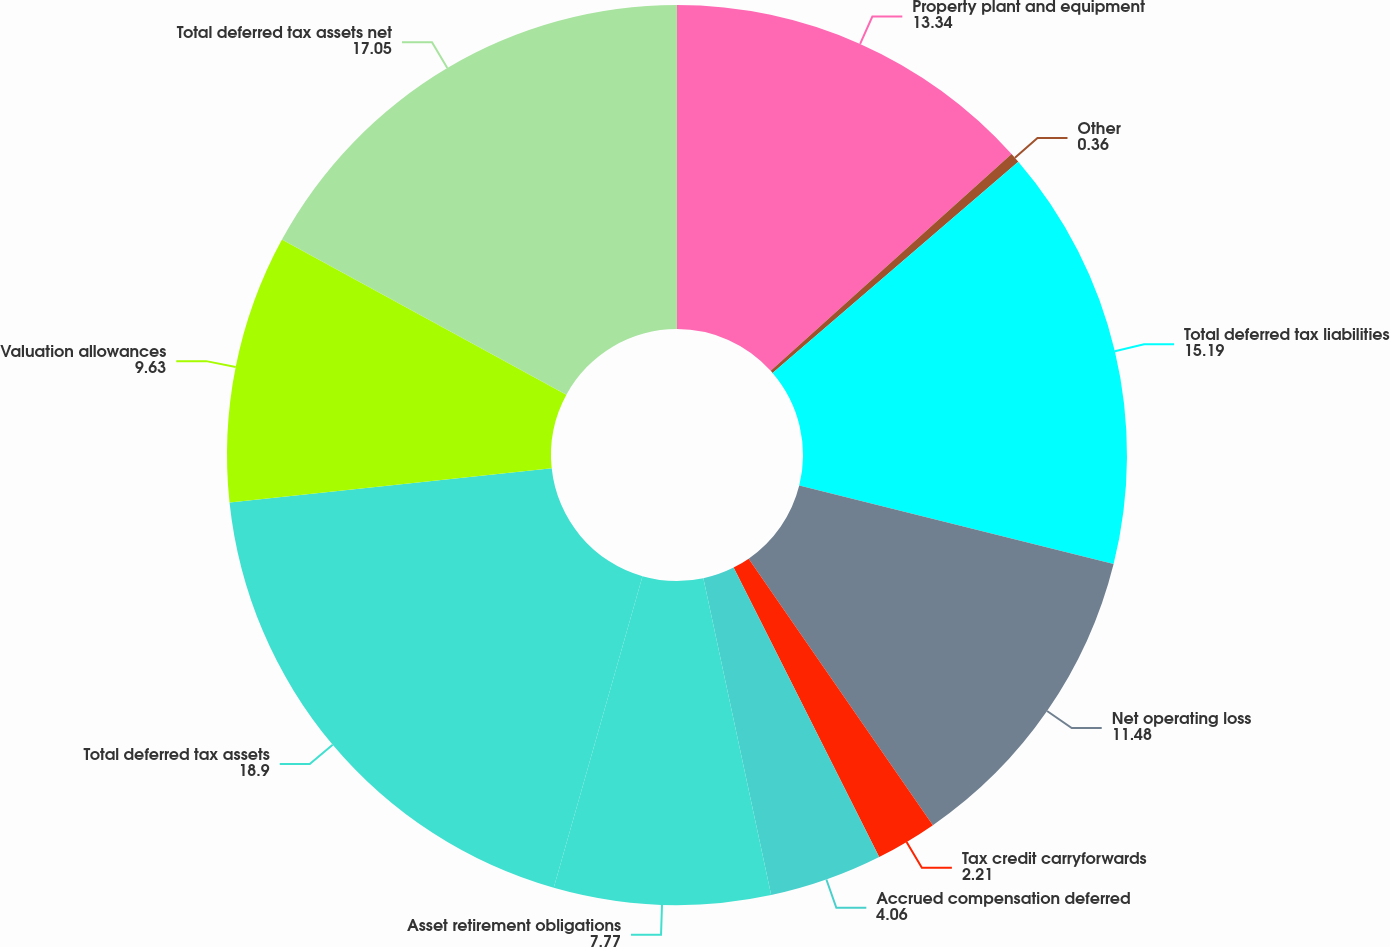Convert chart. <chart><loc_0><loc_0><loc_500><loc_500><pie_chart><fcel>Property plant and equipment<fcel>Other<fcel>Total deferred tax liabilities<fcel>Net operating loss<fcel>Tax credit carryforwards<fcel>Accrued compensation deferred<fcel>Asset retirement obligations<fcel>Total deferred tax assets<fcel>Valuation allowances<fcel>Total deferred tax assets net<nl><fcel>13.34%<fcel>0.36%<fcel>15.19%<fcel>11.48%<fcel>2.21%<fcel>4.06%<fcel>7.77%<fcel>18.9%<fcel>9.63%<fcel>17.05%<nl></chart> 